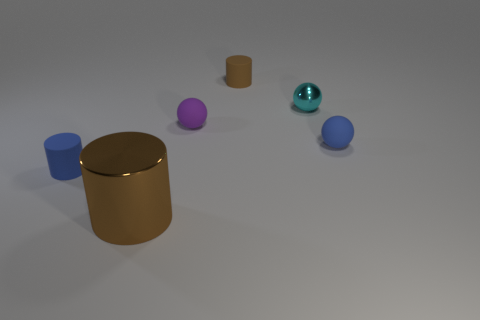What material is the small cylinder to the left of the matte cylinder behind the purple rubber object made of?
Offer a very short reply. Rubber. There is a purple matte object that is the same size as the cyan object; what is its shape?
Offer a very short reply. Sphere. Is the number of small blue matte cylinders less than the number of small blue things?
Provide a short and direct response. Yes. There is a tiny blue thing to the right of the brown matte thing; are there any blue balls to the left of it?
Your response must be concise. No. The brown object that is made of the same material as the blue cylinder is what shape?
Give a very brief answer. Cylinder. Is there anything else that is the same color as the big object?
Make the answer very short. Yes. There is a tiny blue thing that is the same shape as the cyan metal object; what material is it?
Offer a terse response. Rubber. How many other objects are there of the same size as the brown rubber object?
Your answer should be very brief. 4. There is another rubber cylinder that is the same color as the big cylinder; what is its size?
Offer a terse response. Small. Does the object that is in front of the blue cylinder have the same shape as the small cyan object?
Provide a short and direct response. No. 